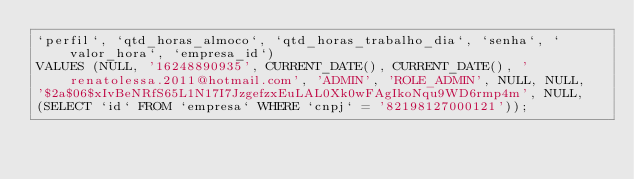<code> <loc_0><loc_0><loc_500><loc_500><_SQL_>`perfil`, `qtd_horas_almoco`, `qtd_horas_trabalho_dia`, `senha`, `valor_hora`, `empresa_id`) 
VALUES (NULL, '16248890935', CURRENT_DATE(), CURRENT_DATE(), 'renatolessa.2011@hotmail.com', 'ADMIN', 'ROLE_ADMIN', NULL, NULL,
'$2a$06$xIvBeNRfS65L1N17I7JzgefzxEuLAL0Xk0wFAgIkoNqu9WD6rmp4m', NULL, 
(SELECT `id` FROM `empresa` WHERE `cnpj` = '82198127000121'));
</code> 